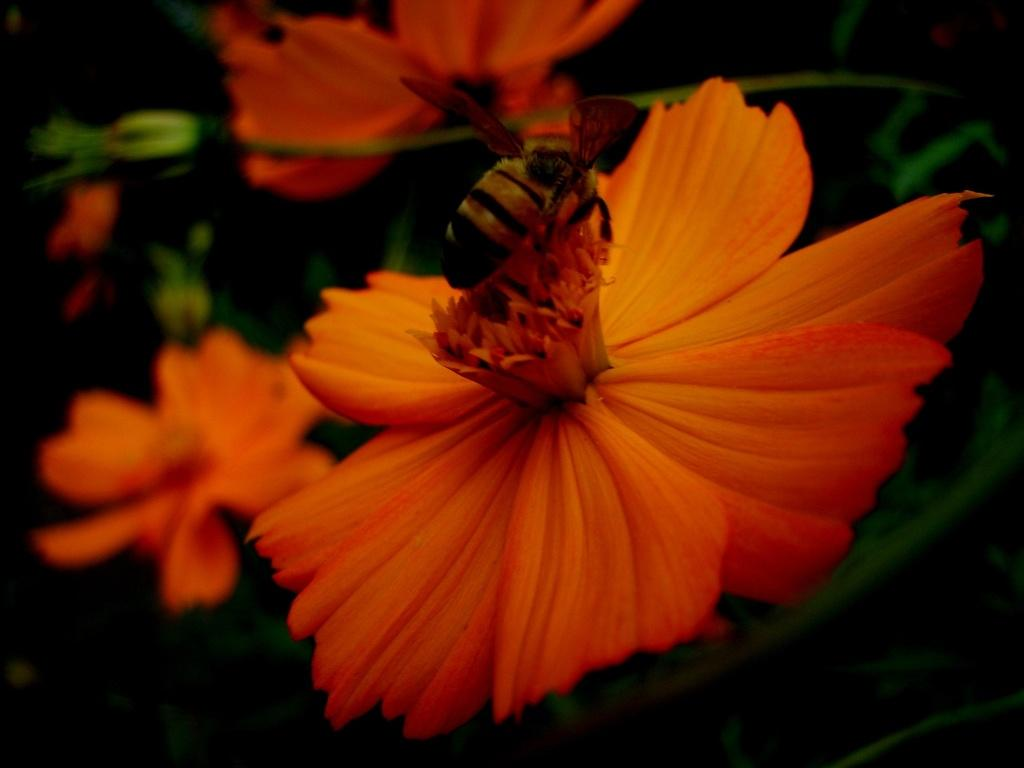What is the main subject of the image? There is a flower in the image. What is sitting on the flower? A honey bee is sitting on the flower. What color is the flower? The flower is orange in color. How many flocks of sheep can be seen in the image? There are no flocks of sheep present in the image; it features a flower with a honey bee on it. What type of arch is visible in the image? There is no arch present in the image; it features a flower with a honey bee on it. 